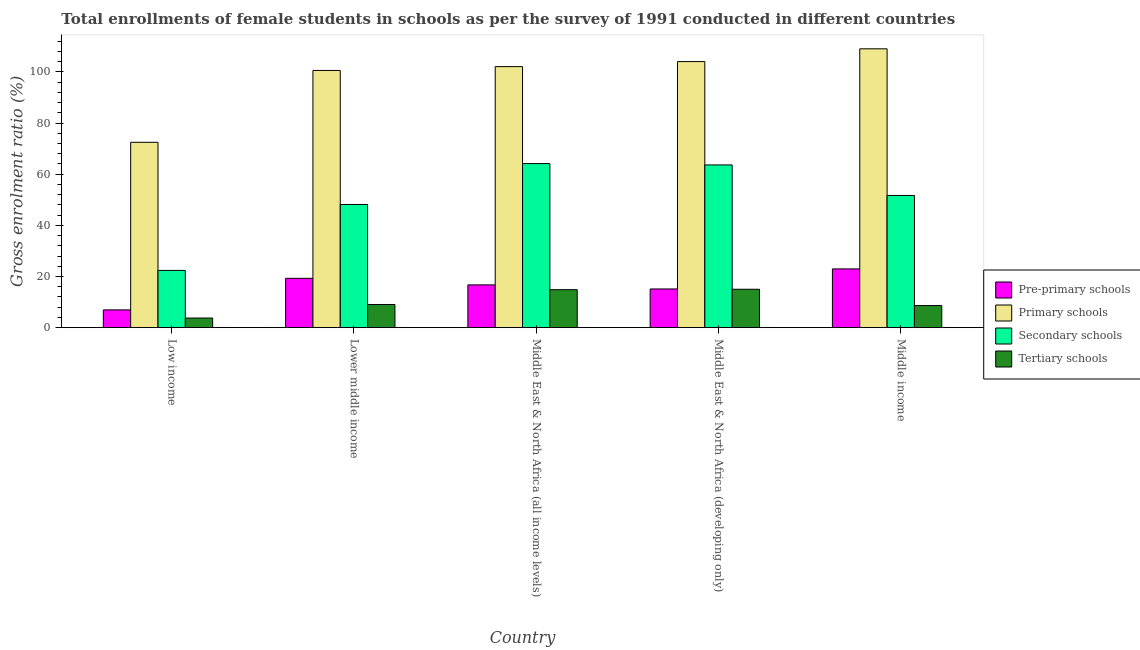How many groups of bars are there?
Your answer should be very brief. 5. How many bars are there on the 4th tick from the right?
Make the answer very short. 4. What is the label of the 3rd group of bars from the left?
Your answer should be compact. Middle East & North Africa (all income levels). In how many cases, is the number of bars for a given country not equal to the number of legend labels?
Make the answer very short. 0. What is the gross enrolment ratio(female) in tertiary schools in Lower middle income?
Keep it short and to the point. 9.06. Across all countries, what is the maximum gross enrolment ratio(female) in pre-primary schools?
Offer a terse response. 22.97. Across all countries, what is the minimum gross enrolment ratio(female) in tertiary schools?
Provide a short and direct response. 3.76. In which country was the gross enrolment ratio(female) in primary schools maximum?
Ensure brevity in your answer.  Middle income. What is the total gross enrolment ratio(female) in tertiary schools in the graph?
Offer a very short reply. 51.34. What is the difference between the gross enrolment ratio(female) in primary schools in Lower middle income and that in Middle income?
Your answer should be very brief. -8.46. What is the difference between the gross enrolment ratio(female) in pre-primary schools in Middle income and the gross enrolment ratio(female) in primary schools in Middle East & North Africa (all income levels)?
Your answer should be compact. -79.1. What is the average gross enrolment ratio(female) in tertiary schools per country?
Your response must be concise. 10.27. What is the difference between the gross enrolment ratio(female) in primary schools and gross enrolment ratio(female) in secondary schools in Middle East & North Africa (all income levels)?
Offer a very short reply. 37.91. What is the ratio of the gross enrolment ratio(female) in tertiary schools in Low income to that in Middle East & North Africa (all income levels)?
Your answer should be compact. 0.25. What is the difference between the highest and the second highest gross enrolment ratio(female) in primary schools?
Offer a terse response. 4.99. What is the difference between the highest and the lowest gross enrolment ratio(female) in pre-primary schools?
Offer a very short reply. 16.02. In how many countries, is the gross enrolment ratio(female) in tertiary schools greater than the average gross enrolment ratio(female) in tertiary schools taken over all countries?
Provide a short and direct response. 2. Is it the case that in every country, the sum of the gross enrolment ratio(female) in tertiary schools and gross enrolment ratio(female) in pre-primary schools is greater than the sum of gross enrolment ratio(female) in primary schools and gross enrolment ratio(female) in secondary schools?
Your answer should be compact. No. What does the 3rd bar from the left in Middle East & North Africa (developing only) represents?
Make the answer very short. Secondary schools. What does the 3rd bar from the right in Middle East & North Africa (developing only) represents?
Provide a succinct answer. Primary schools. Is it the case that in every country, the sum of the gross enrolment ratio(female) in pre-primary schools and gross enrolment ratio(female) in primary schools is greater than the gross enrolment ratio(female) in secondary schools?
Make the answer very short. Yes. How many bars are there?
Provide a succinct answer. 20. Are all the bars in the graph horizontal?
Your answer should be compact. No. How many countries are there in the graph?
Ensure brevity in your answer.  5. What is the difference between two consecutive major ticks on the Y-axis?
Give a very brief answer. 20. Are the values on the major ticks of Y-axis written in scientific E-notation?
Make the answer very short. No. Where does the legend appear in the graph?
Provide a short and direct response. Center right. How are the legend labels stacked?
Your answer should be very brief. Vertical. What is the title of the graph?
Your response must be concise. Total enrollments of female students in schools as per the survey of 1991 conducted in different countries. What is the label or title of the Y-axis?
Make the answer very short. Gross enrolment ratio (%). What is the Gross enrolment ratio (%) in Pre-primary schools in Low income?
Make the answer very short. 6.95. What is the Gross enrolment ratio (%) in Primary schools in Low income?
Provide a succinct answer. 72.48. What is the Gross enrolment ratio (%) of Secondary schools in Low income?
Give a very brief answer. 22.39. What is the Gross enrolment ratio (%) of Tertiary schools in Low income?
Offer a terse response. 3.76. What is the Gross enrolment ratio (%) of Pre-primary schools in Lower middle income?
Provide a short and direct response. 19.3. What is the Gross enrolment ratio (%) of Primary schools in Lower middle income?
Provide a short and direct response. 100.58. What is the Gross enrolment ratio (%) in Secondary schools in Lower middle income?
Provide a short and direct response. 48.17. What is the Gross enrolment ratio (%) of Tertiary schools in Lower middle income?
Offer a very short reply. 9.06. What is the Gross enrolment ratio (%) of Pre-primary schools in Middle East & North Africa (all income levels)?
Your response must be concise. 16.73. What is the Gross enrolment ratio (%) of Primary schools in Middle East & North Africa (all income levels)?
Keep it short and to the point. 102.08. What is the Gross enrolment ratio (%) in Secondary schools in Middle East & North Africa (all income levels)?
Make the answer very short. 64.16. What is the Gross enrolment ratio (%) in Tertiary schools in Middle East & North Africa (all income levels)?
Make the answer very short. 14.85. What is the Gross enrolment ratio (%) in Pre-primary schools in Middle East & North Africa (developing only)?
Ensure brevity in your answer.  15.13. What is the Gross enrolment ratio (%) of Primary schools in Middle East & North Africa (developing only)?
Make the answer very short. 104.04. What is the Gross enrolment ratio (%) in Secondary schools in Middle East & North Africa (developing only)?
Your response must be concise. 63.63. What is the Gross enrolment ratio (%) in Tertiary schools in Middle East & North Africa (developing only)?
Provide a succinct answer. 15.02. What is the Gross enrolment ratio (%) of Pre-primary schools in Middle income?
Ensure brevity in your answer.  22.97. What is the Gross enrolment ratio (%) of Primary schools in Middle income?
Offer a terse response. 109.04. What is the Gross enrolment ratio (%) in Secondary schools in Middle income?
Ensure brevity in your answer.  51.7. What is the Gross enrolment ratio (%) of Tertiary schools in Middle income?
Provide a succinct answer. 8.64. Across all countries, what is the maximum Gross enrolment ratio (%) in Pre-primary schools?
Your answer should be compact. 22.97. Across all countries, what is the maximum Gross enrolment ratio (%) of Primary schools?
Make the answer very short. 109.04. Across all countries, what is the maximum Gross enrolment ratio (%) of Secondary schools?
Offer a terse response. 64.16. Across all countries, what is the maximum Gross enrolment ratio (%) in Tertiary schools?
Give a very brief answer. 15.02. Across all countries, what is the minimum Gross enrolment ratio (%) in Pre-primary schools?
Make the answer very short. 6.95. Across all countries, what is the minimum Gross enrolment ratio (%) of Primary schools?
Provide a succinct answer. 72.48. Across all countries, what is the minimum Gross enrolment ratio (%) of Secondary schools?
Keep it short and to the point. 22.39. Across all countries, what is the minimum Gross enrolment ratio (%) in Tertiary schools?
Give a very brief answer. 3.76. What is the total Gross enrolment ratio (%) of Pre-primary schools in the graph?
Offer a terse response. 81.08. What is the total Gross enrolment ratio (%) in Primary schools in the graph?
Provide a succinct answer. 488.22. What is the total Gross enrolment ratio (%) in Secondary schools in the graph?
Ensure brevity in your answer.  250.05. What is the total Gross enrolment ratio (%) of Tertiary schools in the graph?
Your answer should be very brief. 51.34. What is the difference between the Gross enrolment ratio (%) of Pre-primary schools in Low income and that in Lower middle income?
Your response must be concise. -12.35. What is the difference between the Gross enrolment ratio (%) of Primary schools in Low income and that in Lower middle income?
Make the answer very short. -28.1. What is the difference between the Gross enrolment ratio (%) of Secondary schools in Low income and that in Lower middle income?
Provide a succinct answer. -25.79. What is the difference between the Gross enrolment ratio (%) in Tertiary schools in Low income and that in Lower middle income?
Offer a terse response. -5.3. What is the difference between the Gross enrolment ratio (%) in Pre-primary schools in Low income and that in Middle East & North Africa (all income levels)?
Keep it short and to the point. -9.78. What is the difference between the Gross enrolment ratio (%) of Primary schools in Low income and that in Middle East & North Africa (all income levels)?
Offer a very short reply. -29.6. What is the difference between the Gross enrolment ratio (%) in Secondary schools in Low income and that in Middle East & North Africa (all income levels)?
Offer a terse response. -41.78. What is the difference between the Gross enrolment ratio (%) in Tertiary schools in Low income and that in Middle East & North Africa (all income levels)?
Your answer should be very brief. -11.09. What is the difference between the Gross enrolment ratio (%) in Pre-primary schools in Low income and that in Middle East & North Africa (developing only)?
Ensure brevity in your answer.  -8.19. What is the difference between the Gross enrolment ratio (%) of Primary schools in Low income and that in Middle East & North Africa (developing only)?
Your answer should be compact. -31.56. What is the difference between the Gross enrolment ratio (%) of Secondary schools in Low income and that in Middle East & North Africa (developing only)?
Provide a short and direct response. -41.25. What is the difference between the Gross enrolment ratio (%) in Tertiary schools in Low income and that in Middle East & North Africa (developing only)?
Offer a very short reply. -11.25. What is the difference between the Gross enrolment ratio (%) of Pre-primary schools in Low income and that in Middle income?
Your answer should be very brief. -16.02. What is the difference between the Gross enrolment ratio (%) in Primary schools in Low income and that in Middle income?
Provide a short and direct response. -36.56. What is the difference between the Gross enrolment ratio (%) of Secondary schools in Low income and that in Middle income?
Your answer should be very brief. -29.31. What is the difference between the Gross enrolment ratio (%) in Tertiary schools in Low income and that in Middle income?
Your response must be concise. -4.88. What is the difference between the Gross enrolment ratio (%) in Pre-primary schools in Lower middle income and that in Middle East & North Africa (all income levels)?
Your answer should be very brief. 2.57. What is the difference between the Gross enrolment ratio (%) in Primary schools in Lower middle income and that in Middle East & North Africa (all income levels)?
Offer a terse response. -1.49. What is the difference between the Gross enrolment ratio (%) of Secondary schools in Lower middle income and that in Middle East & North Africa (all income levels)?
Keep it short and to the point. -15.99. What is the difference between the Gross enrolment ratio (%) of Tertiary schools in Lower middle income and that in Middle East & North Africa (all income levels)?
Offer a very short reply. -5.79. What is the difference between the Gross enrolment ratio (%) in Pre-primary schools in Lower middle income and that in Middle East & North Africa (developing only)?
Give a very brief answer. 4.16. What is the difference between the Gross enrolment ratio (%) of Primary schools in Lower middle income and that in Middle East & North Africa (developing only)?
Offer a very short reply. -3.46. What is the difference between the Gross enrolment ratio (%) in Secondary schools in Lower middle income and that in Middle East & North Africa (developing only)?
Your answer should be very brief. -15.46. What is the difference between the Gross enrolment ratio (%) of Tertiary schools in Lower middle income and that in Middle East & North Africa (developing only)?
Offer a very short reply. -5.95. What is the difference between the Gross enrolment ratio (%) in Pre-primary schools in Lower middle income and that in Middle income?
Your response must be concise. -3.68. What is the difference between the Gross enrolment ratio (%) of Primary schools in Lower middle income and that in Middle income?
Provide a succinct answer. -8.46. What is the difference between the Gross enrolment ratio (%) of Secondary schools in Lower middle income and that in Middle income?
Offer a very short reply. -3.53. What is the difference between the Gross enrolment ratio (%) in Tertiary schools in Lower middle income and that in Middle income?
Your response must be concise. 0.42. What is the difference between the Gross enrolment ratio (%) of Pre-primary schools in Middle East & North Africa (all income levels) and that in Middle East & North Africa (developing only)?
Make the answer very short. 1.59. What is the difference between the Gross enrolment ratio (%) in Primary schools in Middle East & North Africa (all income levels) and that in Middle East & North Africa (developing only)?
Offer a very short reply. -1.97. What is the difference between the Gross enrolment ratio (%) in Secondary schools in Middle East & North Africa (all income levels) and that in Middle East & North Africa (developing only)?
Your answer should be compact. 0.53. What is the difference between the Gross enrolment ratio (%) in Tertiary schools in Middle East & North Africa (all income levels) and that in Middle East & North Africa (developing only)?
Make the answer very short. -0.16. What is the difference between the Gross enrolment ratio (%) in Pre-primary schools in Middle East & North Africa (all income levels) and that in Middle income?
Provide a succinct answer. -6.24. What is the difference between the Gross enrolment ratio (%) of Primary schools in Middle East & North Africa (all income levels) and that in Middle income?
Make the answer very short. -6.96. What is the difference between the Gross enrolment ratio (%) of Secondary schools in Middle East & North Africa (all income levels) and that in Middle income?
Ensure brevity in your answer.  12.46. What is the difference between the Gross enrolment ratio (%) of Tertiary schools in Middle East & North Africa (all income levels) and that in Middle income?
Your answer should be compact. 6.21. What is the difference between the Gross enrolment ratio (%) of Pre-primary schools in Middle East & North Africa (developing only) and that in Middle income?
Offer a very short reply. -7.84. What is the difference between the Gross enrolment ratio (%) of Primary schools in Middle East & North Africa (developing only) and that in Middle income?
Provide a succinct answer. -4.99. What is the difference between the Gross enrolment ratio (%) of Secondary schools in Middle East & North Africa (developing only) and that in Middle income?
Your answer should be compact. 11.93. What is the difference between the Gross enrolment ratio (%) in Tertiary schools in Middle East & North Africa (developing only) and that in Middle income?
Keep it short and to the point. 6.37. What is the difference between the Gross enrolment ratio (%) in Pre-primary schools in Low income and the Gross enrolment ratio (%) in Primary schools in Lower middle income?
Make the answer very short. -93.63. What is the difference between the Gross enrolment ratio (%) in Pre-primary schools in Low income and the Gross enrolment ratio (%) in Secondary schools in Lower middle income?
Your answer should be very brief. -41.22. What is the difference between the Gross enrolment ratio (%) of Pre-primary schools in Low income and the Gross enrolment ratio (%) of Tertiary schools in Lower middle income?
Offer a terse response. -2.11. What is the difference between the Gross enrolment ratio (%) in Primary schools in Low income and the Gross enrolment ratio (%) in Secondary schools in Lower middle income?
Ensure brevity in your answer.  24.31. What is the difference between the Gross enrolment ratio (%) in Primary schools in Low income and the Gross enrolment ratio (%) in Tertiary schools in Lower middle income?
Ensure brevity in your answer.  63.42. What is the difference between the Gross enrolment ratio (%) of Secondary schools in Low income and the Gross enrolment ratio (%) of Tertiary schools in Lower middle income?
Provide a succinct answer. 13.32. What is the difference between the Gross enrolment ratio (%) of Pre-primary schools in Low income and the Gross enrolment ratio (%) of Primary schools in Middle East & North Africa (all income levels)?
Make the answer very short. -95.13. What is the difference between the Gross enrolment ratio (%) of Pre-primary schools in Low income and the Gross enrolment ratio (%) of Secondary schools in Middle East & North Africa (all income levels)?
Make the answer very short. -57.21. What is the difference between the Gross enrolment ratio (%) in Pre-primary schools in Low income and the Gross enrolment ratio (%) in Tertiary schools in Middle East & North Africa (all income levels)?
Provide a short and direct response. -7.9. What is the difference between the Gross enrolment ratio (%) in Primary schools in Low income and the Gross enrolment ratio (%) in Secondary schools in Middle East & North Africa (all income levels)?
Make the answer very short. 8.32. What is the difference between the Gross enrolment ratio (%) in Primary schools in Low income and the Gross enrolment ratio (%) in Tertiary schools in Middle East & North Africa (all income levels)?
Keep it short and to the point. 57.63. What is the difference between the Gross enrolment ratio (%) in Secondary schools in Low income and the Gross enrolment ratio (%) in Tertiary schools in Middle East & North Africa (all income levels)?
Offer a terse response. 7.53. What is the difference between the Gross enrolment ratio (%) of Pre-primary schools in Low income and the Gross enrolment ratio (%) of Primary schools in Middle East & North Africa (developing only)?
Offer a terse response. -97.09. What is the difference between the Gross enrolment ratio (%) of Pre-primary schools in Low income and the Gross enrolment ratio (%) of Secondary schools in Middle East & North Africa (developing only)?
Make the answer very short. -56.68. What is the difference between the Gross enrolment ratio (%) of Pre-primary schools in Low income and the Gross enrolment ratio (%) of Tertiary schools in Middle East & North Africa (developing only)?
Offer a terse response. -8.07. What is the difference between the Gross enrolment ratio (%) of Primary schools in Low income and the Gross enrolment ratio (%) of Secondary schools in Middle East & North Africa (developing only)?
Your answer should be compact. 8.85. What is the difference between the Gross enrolment ratio (%) in Primary schools in Low income and the Gross enrolment ratio (%) in Tertiary schools in Middle East & North Africa (developing only)?
Keep it short and to the point. 57.46. What is the difference between the Gross enrolment ratio (%) of Secondary schools in Low income and the Gross enrolment ratio (%) of Tertiary schools in Middle East & North Africa (developing only)?
Give a very brief answer. 7.37. What is the difference between the Gross enrolment ratio (%) of Pre-primary schools in Low income and the Gross enrolment ratio (%) of Primary schools in Middle income?
Provide a short and direct response. -102.09. What is the difference between the Gross enrolment ratio (%) of Pre-primary schools in Low income and the Gross enrolment ratio (%) of Secondary schools in Middle income?
Offer a terse response. -44.75. What is the difference between the Gross enrolment ratio (%) in Pre-primary schools in Low income and the Gross enrolment ratio (%) in Tertiary schools in Middle income?
Offer a very short reply. -1.69. What is the difference between the Gross enrolment ratio (%) in Primary schools in Low income and the Gross enrolment ratio (%) in Secondary schools in Middle income?
Provide a succinct answer. 20.78. What is the difference between the Gross enrolment ratio (%) in Primary schools in Low income and the Gross enrolment ratio (%) in Tertiary schools in Middle income?
Offer a very short reply. 63.84. What is the difference between the Gross enrolment ratio (%) of Secondary schools in Low income and the Gross enrolment ratio (%) of Tertiary schools in Middle income?
Your answer should be very brief. 13.74. What is the difference between the Gross enrolment ratio (%) of Pre-primary schools in Lower middle income and the Gross enrolment ratio (%) of Primary schools in Middle East & North Africa (all income levels)?
Offer a terse response. -82.78. What is the difference between the Gross enrolment ratio (%) of Pre-primary schools in Lower middle income and the Gross enrolment ratio (%) of Secondary schools in Middle East & North Africa (all income levels)?
Your response must be concise. -44.87. What is the difference between the Gross enrolment ratio (%) of Pre-primary schools in Lower middle income and the Gross enrolment ratio (%) of Tertiary schools in Middle East & North Africa (all income levels)?
Keep it short and to the point. 4.44. What is the difference between the Gross enrolment ratio (%) of Primary schools in Lower middle income and the Gross enrolment ratio (%) of Secondary schools in Middle East & North Africa (all income levels)?
Offer a terse response. 36.42. What is the difference between the Gross enrolment ratio (%) in Primary schools in Lower middle income and the Gross enrolment ratio (%) in Tertiary schools in Middle East & North Africa (all income levels)?
Give a very brief answer. 85.73. What is the difference between the Gross enrolment ratio (%) of Secondary schools in Lower middle income and the Gross enrolment ratio (%) of Tertiary schools in Middle East & North Africa (all income levels)?
Your response must be concise. 33.32. What is the difference between the Gross enrolment ratio (%) in Pre-primary schools in Lower middle income and the Gross enrolment ratio (%) in Primary schools in Middle East & North Africa (developing only)?
Keep it short and to the point. -84.75. What is the difference between the Gross enrolment ratio (%) in Pre-primary schools in Lower middle income and the Gross enrolment ratio (%) in Secondary schools in Middle East & North Africa (developing only)?
Your answer should be very brief. -44.34. What is the difference between the Gross enrolment ratio (%) in Pre-primary schools in Lower middle income and the Gross enrolment ratio (%) in Tertiary schools in Middle East & North Africa (developing only)?
Offer a very short reply. 4.28. What is the difference between the Gross enrolment ratio (%) in Primary schools in Lower middle income and the Gross enrolment ratio (%) in Secondary schools in Middle East & North Africa (developing only)?
Offer a very short reply. 36.95. What is the difference between the Gross enrolment ratio (%) of Primary schools in Lower middle income and the Gross enrolment ratio (%) of Tertiary schools in Middle East & North Africa (developing only)?
Ensure brevity in your answer.  85.56. What is the difference between the Gross enrolment ratio (%) in Secondary schools in Lower middle income and the Gross enrolment ratio (%) in Tertiary schools in Middle East & North Africa (developing only)?
Keep it short and to the point. 33.16. What is the difference between the Gross enrolment ratio (%) in Pre-primary schools in Lower middle income and the Gross enrolment ratio (%) in Primary schools in Middle income?
Ensure brevity in your answer.  -89.74. What is the difference between the Gross enrolment ratio (%) of Pre-primary schools in Lower middle income and the Gross enrolment ratio (%) of Secondary schools in Middle income?
Your response must be concise. -32.4. What is the difference between the Gross enrolment ratio (%) in Pre-primary schools in Lower middle income and the Gross enrolment ratio (%) in Tertiary schools in Middle income?
Give a very brief answer. 10.65. What is the difference between the Gross enrolment ratio (%) in Primary schools in Lower middle income and the Gross enrolment ratio (%) in Secondary schools in Middle income?
Provide a succinct answer. 48.88. What is the difference between the Gross enrolment ratio (%) of Primary schools in Lower middle income and the Gross enrolment ratio (%) of Tertiary schools in Middle income?
Your answer should be compact. 91.94. What is the difference between the Gross enrolment ratio (%) of Secondary schools in Lower middle income and the Gross enrolment ratio (%) of Tertiary schools in Middle income?
Offer a terse response. 39.53. What is the difference between the Gross enrolment ratio (%) of Pre-primary schools in Middle East & North Africa (all income levels) and the Gross enrolment ratio (%) of Primary schools in Middle East & North Africa (developing only)?
Your response must be concise. -87.31. What is the difference between the Gross enrolment ratio (%) in Pre-primary schools in Middle East & North Africa (all income levels) and the Gross enrolment ratio (%) in Secondary schools in Middle East & North Africa (developing only)?
Your answer should be compact. -46.9. What is the difference between the Gross enrolment ratio (%) in Pre-primary schools in Middle East & North Africa (all income levels) and the Gross enrolment ratio (%) in Tertiary schools in Middle East & North Africa (developing only)?
Provide a short and direct response. 1.71. What is the difference between the Gross enrolment ratio (%) in Primary schools in Middle East & North Africa (all income levels) and the Gross enrolment ratio (%) in Secondary schools in Middle East & North Africa (developing only)?
Ensure brevity in your answer.  38.44. What is the difference between the Gross enrolment ratio (%) in Primary schools in Middle East & North Africa (all income levels) and the Gross enrolment ratio (%) in Tertiary schools in Middle East & North Africa (developing only)?
Provide a short and direct response. 87.06. What is the difference between the Gross enrolment ratio (%) in Secondary schools in Middle East & North Africa (all income levels) and the Gross enrolment ratio (%) in Tertiary schools in Middle East & North Africa (developing only)?
Give a very brief answer. 49.15. What is the difference between the Gross enrolment ratio (%) of Pre-primary schools in Middle East & North Africa (all income levels) and the Gross enrolment ratio (%) of Primary schools in Middle income?
Provide a succinct answer. -92.31. What is the difference between the Gross enrolment ratio (%) in Pre-primary schools in Middle East & North Africa (all income levels) and the Gross enrolment ratio (%) in Secondary schools in Middle income?
Provide a short and direct response. -34.97. What is the difference between the Gross enrolment ratio (%) in Pre-primary schools in Middle East & North Africa (all income levels) and the Gross enrolment ratio (%) in Tertiary schools in Middle income?
Provide a short and direct response. 8.09. What is the difference between the Gross enrolment ratio (%) of Primary schools in Middle East & North Africa (all income levels) and the Gross enrolment ratio (%) of Secondary schools in Middle income?
Your answer should be compact. 50.38. What is the difference between the Gross enrolment ratio (%) of Primary schools in Middle East & North Africa (all income levels) and the Gross enrolment ratio (%) of Tertiary schools in Middle income?
Ensure brevity in your answer.  93.43. What is the difference between the Gross enrolment ratio (%) in Secondary schools in Middle East & North Africa (all income levels) and the Gross enrolment ratio (%) in Tertiary schools in Middle income?
Your answer should be very brief. 55.52. What is the difference between the Gross enrolment ratio (%) in Pre-primary schools in Middle East & North Africa (developing only) and the Gross enrolment ratio (%) in Primary schools in Middle income?
Make the answer very short. -93.9. What is the difference between the Gross enrolment ratio (%) of Pre-primary schools in Middle East & North Africa (developing only) and the Gross enrolment ratio (%) of Secondary schools in Middle income?
Your answer should be compact. -36.56. What is the difference between the Gross enrolment ratio (%) in Pre-primary schools in Middle East & North Africa (developing only) and the Gross enrolment ratio (%) in Tertiary schools in Middle income?
Your answer should be compact. 6.49. What is the difference between the Gross enrolment ratio (%) in Primary schools in Middle East & North Africa (developing only) and the Gross enrolment ratio (%) in Secondary schools in Middle income?
Keep it short and to the point. 52.35. What is the difference between the Gross enrolment ratio (%) in Primary schools in Middle East & North Africa (developing only) and the Gross enrolment ratio (%) in Tertiary schools in Middle income?
Provide a succinct answer. 95.4. What is the difference between the Gross enrolment ratio (%) of Secondary schools in Middle East & North Africa (developing only) and the Gross enrolment ratio (%) of Tertiary schools in Middle income?
Ensure brevity in your answer.  54.99. What is the average Gross enrolment ratio (%) of Pre-primary schools per country?
Provide a succinct answer. 16.22. What is the average Gross enrolment ratio (%) of Primary schools per country?
Offer a terse response. 97.64. What is the average Gross enrolment ratio (%) in Secondary schools per country?
Ensure brevity in your answer.  50.01. What is the average Gross enrolment ratio (%) of Tertiary schools per country?
Offer a terse response. 10.27. What is the difference between the Gross enrolment ratio (%) of Pre-primary schools and Gross enrolment ratio (%) of Primary schools in Low income?
Your answer should be very brief. -65.53. What is the difference between the Gross enrolment ratio (%) of Pre-primary schools and Gross enrolment ratio (%) of Secondary schools in Low income?
Provide a short and direct response. -15.44. What is the difference between the Gross enrolment ratio (%) of Pre-primary schools and Gross enrolment ratio (%) of Tertiary schools in Low income?
Your answer should be compact. 3.18. What is the difference between the Gross enrolment ratio (%) of Primary schools and Gross enrolment ratio (%) of Secondary schools in Low income?
Keep it short and to the point. 50.09. What is the difference between the Gross enrolment ratio (%) of Primary schools and Gross enrolment ratio (%) of Tertiary schools in Low income?
Your response must be concise. 68.72. What is the difference between the Gross enrolment ratio (%) of Secondary schools and Gross enrolment ratio (%) of Tertiary schools in Low income?
Your response must be concise. 18.62. What is the difference between the Gross enrolment ratio (%) in Pre-primary schools and Gross enrolment ratio (%) in Primary schools in Lower middle income?
Provide a short and direct response. -81.28. What is the difference between the Gross enrolment ratio (%) in Pre-primary schools and Gross enrolment ratio (%) in Secondary schools in Lower middle income?
Ensure brevity in your answer.  -28.88. What is the difference between the Gross enrolment ratio (%) of Pre-primary schools and Gross enrolment ratio (%) of Tertiary schools in Lower middle income?
Offer a terse response. 10.23. What is the difference between the Gross enrolment ratio (%) in Primary schools and Gross enrolment ratio (%) in Secondary schools in Lower middle income?
Your response must be concise. 52.41. What is the difference between the Gross enrolment ratio (%) in Primary schools and Gross enrolment ratio (%) in Tertiary schools in Lower middle income?
Provide a succinct answer. 91.52. What is the difference between the Gross enrolment ratio (%) in Secondary schools and Gross enrolment ratio (%) in Tertiary schools in Lower middle income?
Keep it short and to the point. 39.11. What is the difference between the Gross enrolment ratio (%) in Pre-primary schools and Gross enrolment ratio (%) in Primary schools in Middle East & North Africa (all income levels)?
Your answer should be compact. -85.35. What is the difference between the Gross enrolment ratio (%) in Pre-primary schools and Gross enrolment ratio (%) in Secondary schools in Middle East & North Africa (all income levels)?
Your answer should be very brief. -47.43. What is the difference between the Gross enrolment ratio (%) in Pre-primary schools and Gross enrolment ratio (%) in Tertiary schools in Middle East & North Africa (all income levels)?
Your answer should be compact. 1.88. What is the difference between the Gross enrolment ratio (%) of Primary schools and Gross enrolment ratio (%) of Secondary schools in Middle East & North Africa (all income levels)?
Give a very brief answer. 37.91. What is the difference between the Gross enrolment ratio (%) in Primary schools and Gross enrolment ratio (%) in Tertiary schools in Middle East & North Africa (all income levels)?
Your response must be concise. 87.22. What is the difference between the Gross enrolment ratio (%) in Secondary schools and Gross enrolment ratio (%) in Tertiary schools in Middle East & North Africa (all income levels)?
Provide a succinct answer. 49.31. What is the difference between the Gross enrolment ratio (%) in Pre-primary schools and Gross enrolment ratio (%) in Primary schools in Middle East & North Africa (developing only)?
Offer a terse response. -88.91. What is the difference between the Gross enrolment ratio (%) of Pre-primary schools and Gross enrolment ratio (%) of Secondary schools in Middle East & North Africa (developing only)?
Provide a short and direct response. -48.5. What is the difference between the Gross enrolment ratio (%) of Pre-primary schools and Gross enrolment ratio (%) of Tertiary schools in Middle East & North Africa (developing only)?
Keep it short and to the point. 0.12. What is the difference between the Gross enrolment ratio (%) in Primary schools and Gross enrolment ratio (%) in Secondary schools in Middle East & North Africa (developing only)?
Give a very brief answer. 40.41. What is the difference between the Gross enrolment ratio (%) in Primary schools and Gross enrolment ratio (%) in Tertiary schools in Middle East & North Africa (developing only)?
Ensure brevity in your answer.  89.03. What is the difference between the Gross enrolment ratio (%) of Secondary schools and Gross enrolment ratio (%) of Tertiary schools in Middle East & North Africa (developing only)?
Make the answer very short. 48.62. What is the difference between the Gross enrolment ratio (%) in Pre-primary schools and Gross enrolment ratio (%) in Primary schools in Middle income?
Keep it short and to the point. -86.07. What is the difference between the Gross enrolment ratio (%) of Pre-primary schools and Gross enrolment ratio (%) of Secondary schools in Middle income?
Provide a succinct answer. -28.73. What is the difference between the Gross enrolment ratio (%) of Pre-primary schools and Gross enrolment ratio (%) of Tertiary schools in Middle income?
Your response must be concise. 14.33. What is the difference between the Gross enrolment ratio (%) in Primary schools and Gross enrolment ratio (%) in Secondary schools in Middle income?
Give a very brief answer. 57.34. What is the difference between the Gross enrolment ratio (%) of Primary schools and Gross enrolment ratio (%) of Tertiary schools in Middle income?
Give a very brief answer. 100.4. What is the difference between the Gross enrolment ratio (%) of Secondary schools and Gross enrolment ratio (%) of Tertiary schools in Middle income?
Provide a short and direct response. 43.06. What is the ratio of the Gross enrolment ratio (%) of Pre-primary schools in Low income to that in Lower middle income?
Keep it short and to the point. 0.36. What is the ratio of the Gross enrolment ratio (%) in Primary schools in Low income to that in Lower middle income?
Provide a short and direct response. 0.72. What is the ratio of the Gross enrolment ratio (%) of Secondary schools in Low income to that in Lower middle income?
Provide a short and direct response. 0.46. What is the ratio of the Gross enrolment ratio (%) of Tertiary schools in Low income to that in Lower middle income?
Offer a terse response. 0.42. What is the ratio of the Gross enrolment ratio (%) in Pre-primary schools in Low income to that in Middle East & North Africa (all income levels)?
Provide a succinct answer. 0.42. What is the ratio of the Gross enrolment ratio (%) in Primary schools in Low income to that in Middle East & North Africa (all income levels)?
Give a very brief answer. 0.71. What is the ratio of the Gross enrolment ratio (%) in Secondary schools in Low income to that in Middle East & North Africa (all income levels)?
Ensure brevity in your answer.  0.35. What is the ratio of the Gross enrolment ratio (%) of Tertiary schools in Low income to that in Middle East & North Africa (all income levels)?
Provide a short and direct response. 0.25. What is the ratio of the Gross enrolment ratio (%) in Pre-primary schools in Low income to that in Middle East & North Africa (developing only)?
Provide a short and direct response. 0.46. What is the ratio of the Gross enrolment ratio (%) of Primary schools in Low income to that in Middle East & North Africa (developing only)?
Give a very brief answer. 0.7. What is the ratio of the Gross enrolment ratio (%) in Secondary schools in Low income to that in Middle East & North Africa (developing only)?
Ensure brevity in your answer.  0.35. What is the ratio of the Gross enrolment ratio (%) in Tertiary schools in Low income to that in Middle East & North Africa (developing only)?
Give a very brief answer. 0.25. What is the ratio of the Gross enrolment ratio (%) of Pre-primary schools in Low income to that in Middle income?
Your response must be concise. 0.3. What is the ratio of the Gross enrolment ratio (%) of Primary schools in Low income to that in Middle income?
Give a very brief answer. 0.66. What is the ratio of the Gross enrolment ratio (%) in Secondary schools in Low income to that in Middle income?
Provide a succinct answer. 0.43. What is the ratio of the Gross enrolment ratio (%) in Tertiary schools in Low income to that in Middle income?
Provide a succinct answer. 0.44. What is the ratio of the Gross enrolment ratio (%) of Pre-primary schools in Lower middle income to that in Middle East & North Africa (all income levels)?
Provide a short and direct response. 1.15. What is the ratio of the Gross enrolment ratio (%) of Primary schools in Lower middle income to that in Middle East & North Africa (all income levels)?
Your response must be concise. 0.99. What is the ratio of the Gross enrolment ratio (%) in Secondary schools in Lower middle income to that in Middle East & North Africa (all income levels)?
Offer a terse response. 0.75. What is the ratio of the Gross enrolment ratio (%) of Tertiary schools in Lower middle income to that in Middle East & North Africa (all income levels)?
Your response must be concise. 0.61. What is the ratio of the Gross enrolment ratio (%) of Pre-primary schools in Lower middle income to that in Middle East & North Africa (developing only)?
Provide a succinct answer. 1.27. What is the ratio of the Gross enrolment ratio (%) in Primary schools in Lower middle income to that in Middle East & North Africa (developing only)?
Offer a very short reply. 0.97. What is the ratio of the Gross enrolment ratio (%) of Secondary schools in Lower middle income to that in Middle East & North Africa (developing only)?
Provide a short and direct response. 0.76. What is the ratio of the Gross enrolment ratio (%) in Tertiary schools in Lower middle income to that in Middle East & North Africa (developing only)?
Make the answer very short. 0.6. What is the ratio of the Gross enrolment ratio (%) in Pre-primary schools in Lower middle income to that in Middle income?
Make the answer very short. 0.84. What is the ratio of the Gross enrolment ratio (%) of Primary schools in Lower middle income to that in Middle income?
Keep it short and to the point. 0.92. What is the ratio of the Gross enrolment ratio (%) of Secondary schools in Lower middle income to that in Middle income?
Your response must be concise. 0.93. What is the ratio of the Gross enrolment ratio (%) in Tertiary schools in Lower middle income to that in Middle income?
Your response must be concise. 1.05. What is the ratio of the Gross enrolment ratio (%) in Pre-primary schools in Middle East & North Africa (all income levels) to that in Middle East & North Africa (developing only)?
Ensure brevity in your answer.  1.11. What is the ratio of the Gross enrolment ratio (%) of Primary schools in Middle East & North Africa (all income levels) to that in Middle East & North Africa (developing only)?
Offer a terse response. 0.98. What is the ratio of the Gross enrolment ratio (%) of Secondary schools in Middle East & North Africa (all income levels) to that in Middle East & North Africa (developing only)?
Provide a short and direct response. 1.01. What is the ratio of the Gross enrolment ratio (%) of Pre-primary schools in Middle East & North Africa (all income levels) to that in Middle income?
Offer a terse response. 0.73. What is the ratio of the Gross enrolment ratio (%) of Primary schools in Middle East & North Africa (all income levels) to that in Middle income?
Make the answer very short. 0.94. What is the ratio of the Gross enrolment ratio (%) of Secondary schools in Middle East & North Africa (all income levels) to that in Middle income?
Your answer should be very brief. 1.24. What is the ratio of the Gross enrolment ratio (%) of Tertiary schools in Middle East & North Africa (all income levels) to that in Middle income?
Give a very brief answer. 1.72. What is the ratio of the Gross enrolment ratio (%) of Pre-primary schools in Middle East & North Africa (developing only) to that in Middle income?
Make the answer very short. 0.66. What is the ratio of the Gross enrolment ratio (%) of Primary schools in Middle East & North Africa (developing only) to that in Middle income?
Provide a short and direct response. 0.95. What is the ratio of the Gross enrolment ratio (%) of Secondary schools in Middle East & North Africa (developing only) to that in Middle income?
Keep it short and to the point. 1.23. What is the ratio of the Gross enrolment ratio (%) of Tertiary schools in Middle East & North Africa (developing only) to that in Middle income?
Your answer should be very brief. 1.74. What is the difference between the highest and the second highest Gross enrolment ratio (%) in Pre-primary schools?
Provide a short and direct response. 3.68. What is the difference between the highest and the second highest Gross enrolment ratio (%) in Primary schools?
Offer a very short reply. 4.99. What is the difference between the highest and the second highest Gross enrolment ratio (%) of Secondary schools?
Ensure brevity in your answer.  0.53. What is the difference between the highest and the second highest Gross enrolment ratio (%) of Tertiary schools?
Your answer should be compact. 0.16. What is the difference between the highest and the lowest Gross enrolment ratio (%) in Pre-primary schools?
Give a very brief answer. 16.02. What is the difference between the highest and the lowest Gross enrolment ratio (%) in Primary schools?
Make the answer very short. 36.56. What is the difference between the highest and the lowest Gross enrolment ratio (%) in Secondary schools?
Provide a succinct answer. 41.78. What is the difference between the highest and the lowest Gross enrolment ratio (%) in Tertiary schools?
Give a very brief answer. 11.25. 